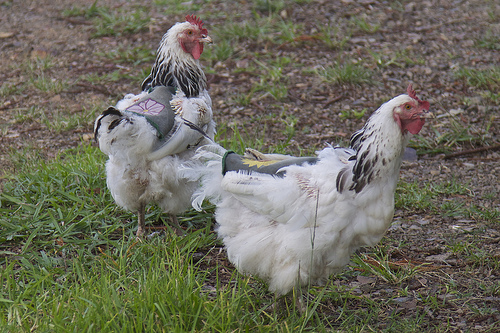<image>
Is there a chicken above the grass? No. The chicken is not positioned above the grass. The vertical arrangement shows a different relationship. 